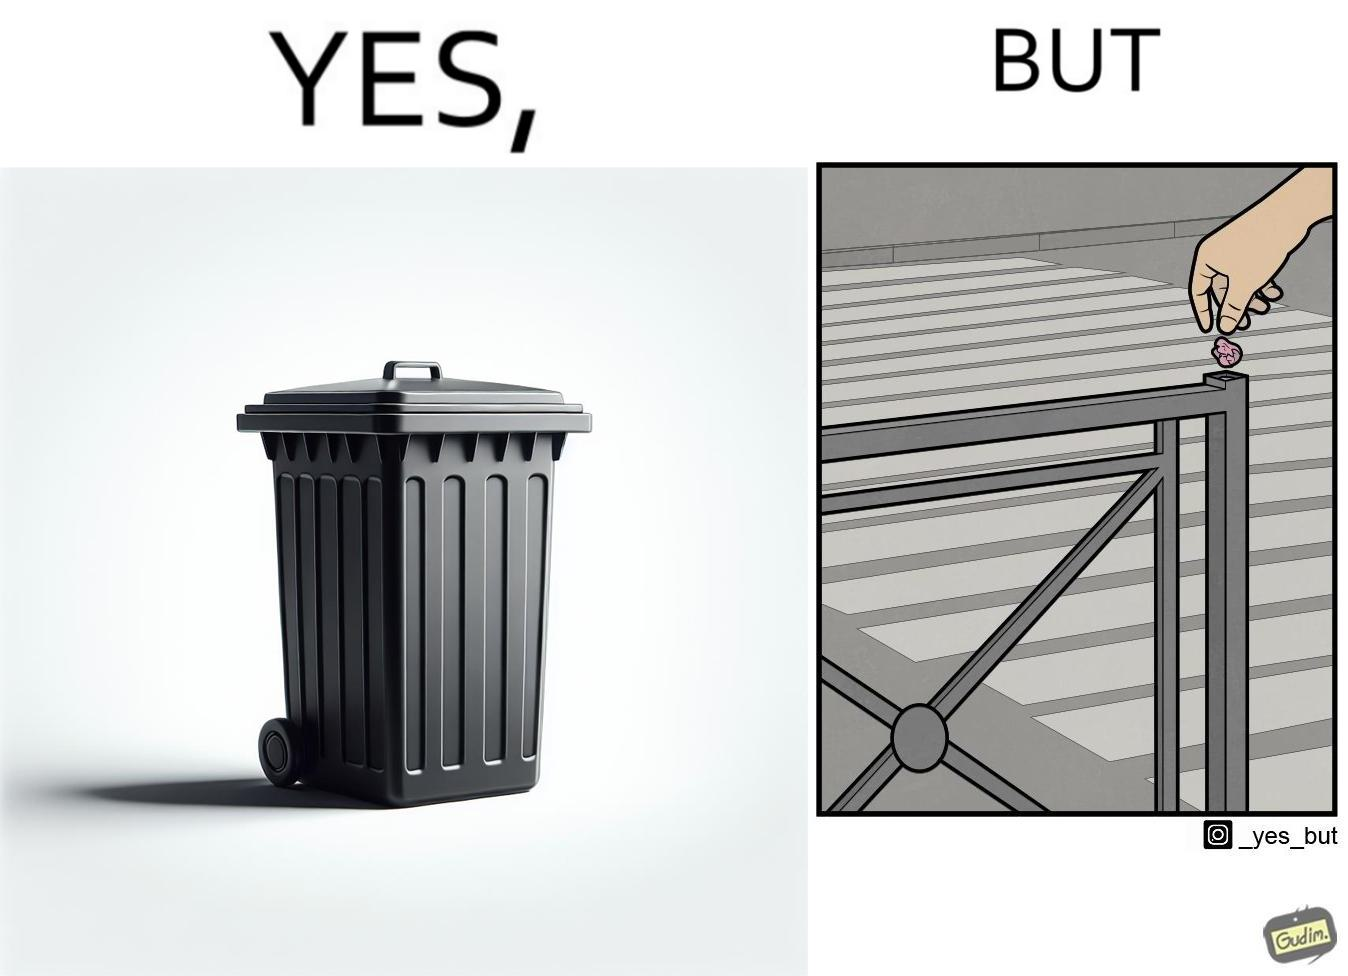Is there satirical content in this image? Yes, this image is satirical. 